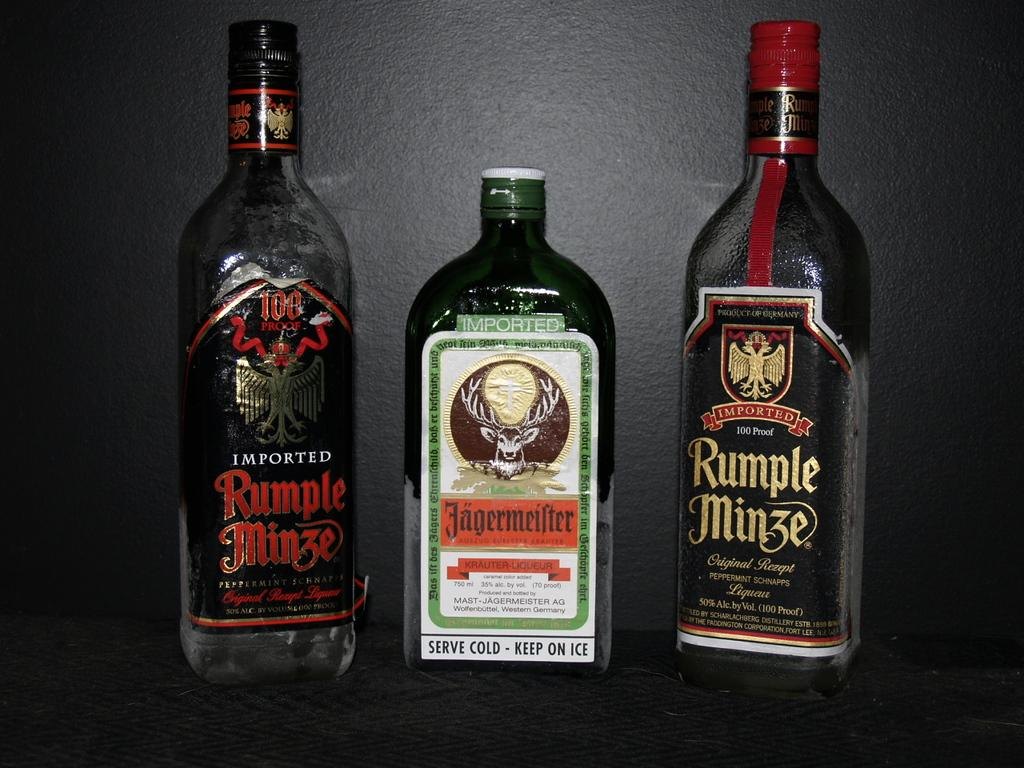<image>
Summarize the visual content of the image. Two bottles of Rumplemize are sitting next to a bottle of Jagemeister. 